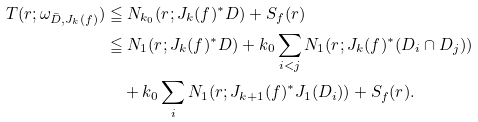<formula> <loc_0><loc_0><loc_500><loc_500>T ( r ; \omega _ { \bar { D } , J _ { k } ( f ) } ) & \leqq N _ { k _ { 0 } } ( r ; J _ { k } ( f ) ^ { * } D ) + S _ { f } ( r ) \\ & \leqq N _ { 1 } ( r ; J _ { k } ( f ) ^ { * } D ) + k _ { 0 } \sum _ { i < j } N _ { 1 } ( r ; J _ { k } ( f ) ^ { * } ( D _ { i } \cap D _ { j } ) ) \\ & \quad + k _ { 0 } \sum _ { i } N _ { 1 } ( r ; J _ { k + 1 } ( f ) ^ { * } J _ { 1 } ( D _ { i } ) ) + S _ { f } ( r ) .</formula> 